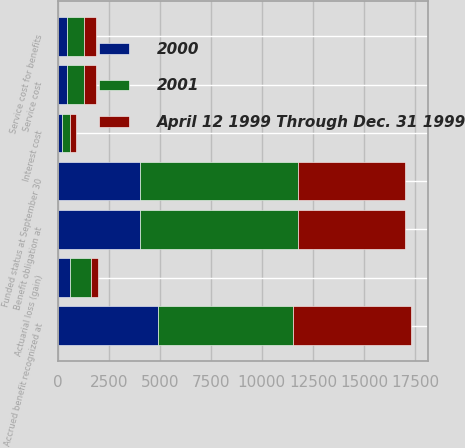Convert chart to OTSL. <chart><loc_0><loc_0><loc_500><loc_500><stacked_bar_chart><ecel><fcel>Benefit obligation at<fcel>Service cost<fcel>Interest cost<fcel>Actuarial loss (gain)<fcel>Funded status at September 30<fcel>Accrued benefit recognized at<fcel>Service cost for benefits<nl><fcel>2001<fcel>7703<fcel>855<fcel>406<fcel>1034<fcel>7703<fcel>6644<fcel>855<nl><fcel>April 12 1999 Through Dec. 31 1999<fcel>5276<fcel>587<fcel>304<fcel>341<fcel>5276<fcel>5755<fcel>587<nl><fcel>2000<fcel>4044<fcel>441<fcel>210<fcel>614<fcel>4044<fcel>4893<fcel>441<nl></chart> 